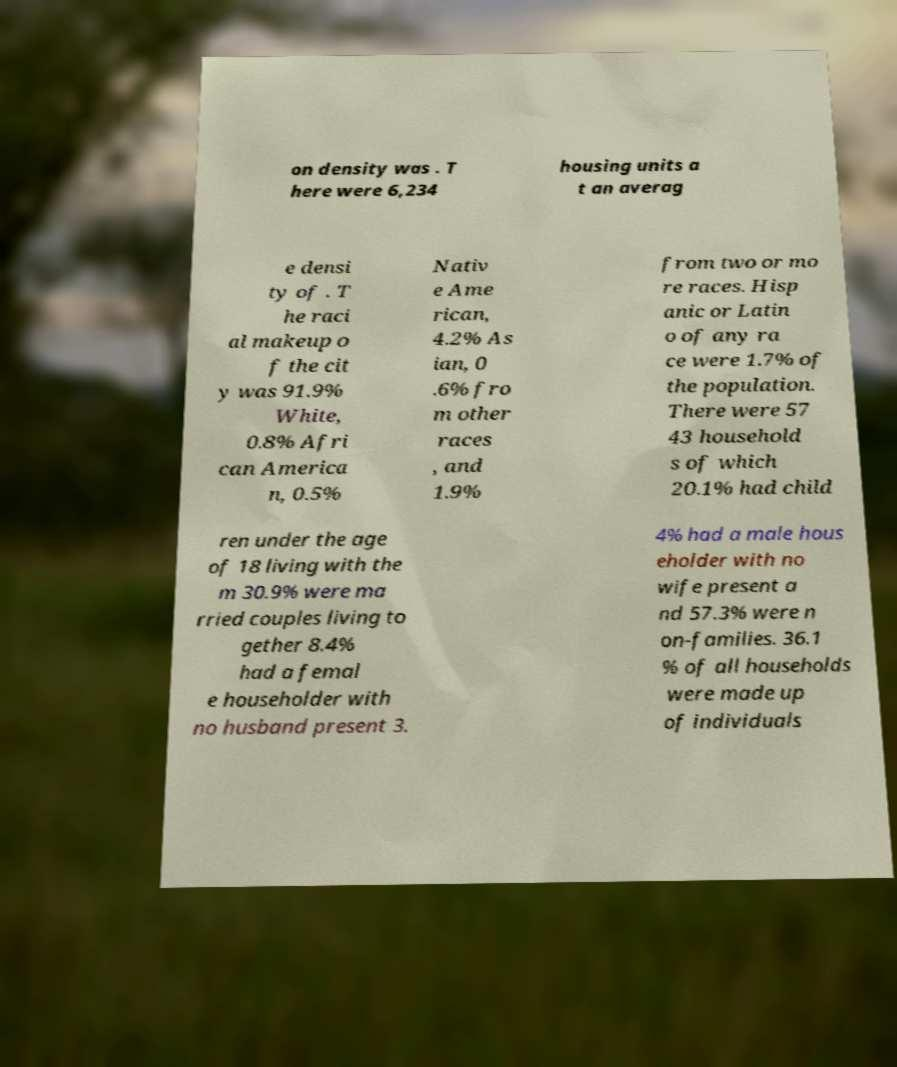Please identify and transcribe the text found in this image. on density was . T here were 6,234 housing units a t an averag e densi ty of . T he raci al makeup o f the cit y was 91.9% White, 0.8% Afri can America n, 0.5% Nativ e Ame rican, 4.2% As ian, 0 .6% fro m other races , and 1.9% from two or mo re races. Hisp anic or Latin o of any ra ce were 1.7% of the population. There were 57 43 household s of which 20.1% had child ren under the age of 18 living with the m 30.9% were ma rried couples living to gether 8.4% had a femal e householder with no husband present 3. 4% had a male hous eholder with no wife present a nd 57.3% were n on-families. 36.1 % of all households were made up of individuals 